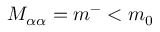Convert formula to latex. <formula><loc_0><loc_0><loc_500><loc_500>M _ { \alpha \alpha } = m ^ { - } < m _ { 0 }</formula> 